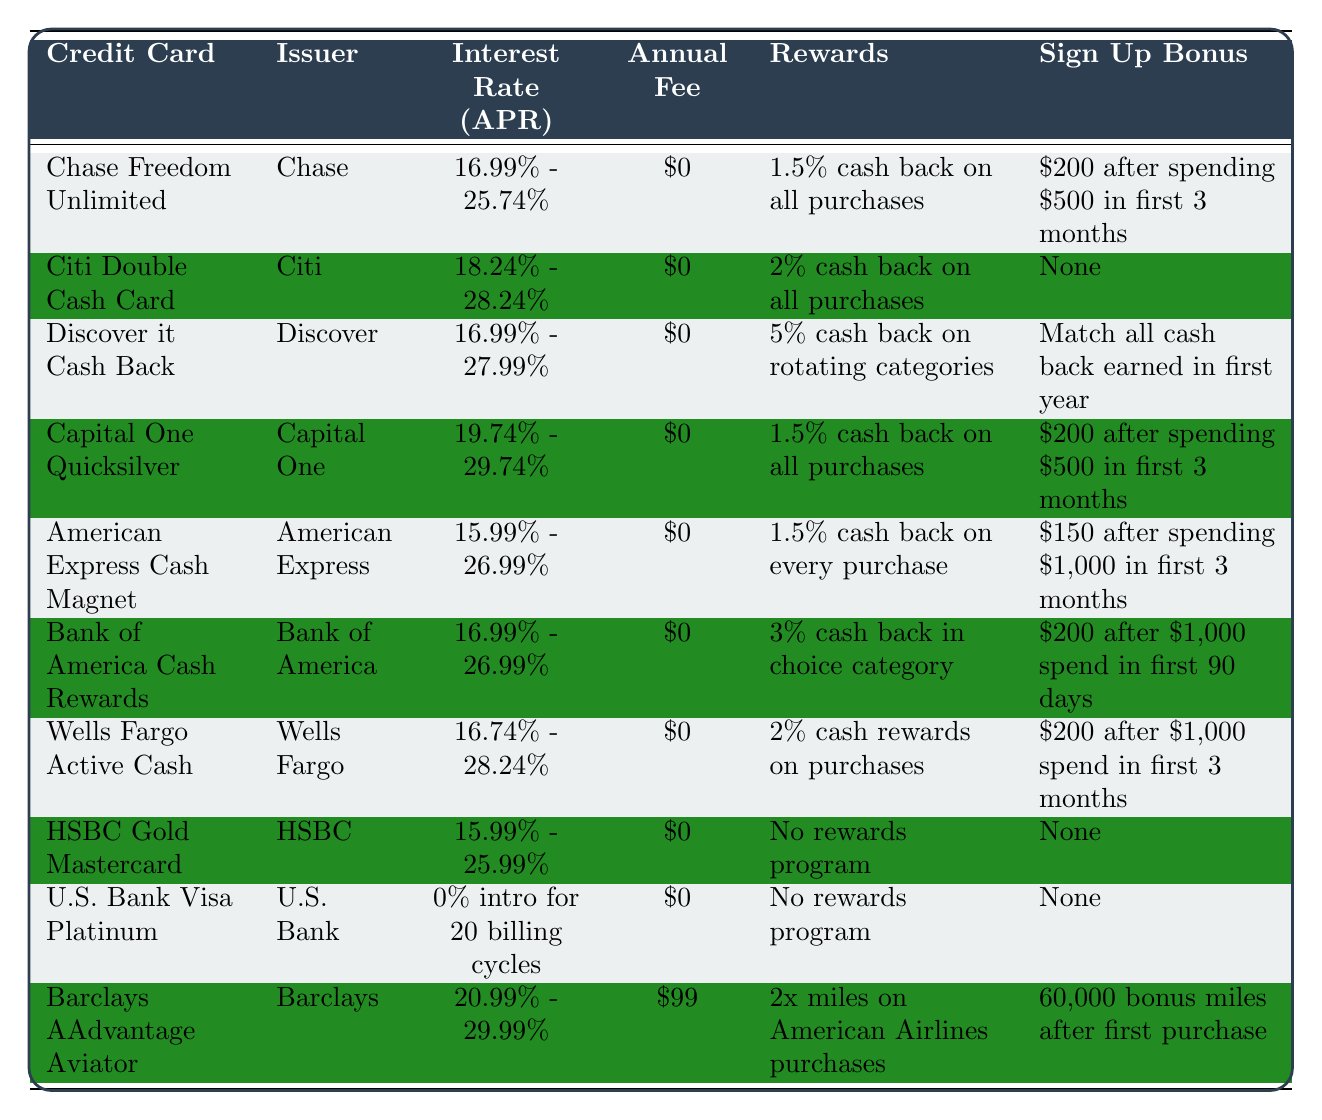What is the lowest interest rate offered among the credit cards in the table? The U.S. Bank Visa Platinum Card has a 0% intro interest rate for 20 billing cycles, which is lower than any other card listed in the table.
Answer: 0% Which credit card offers the highest potential interest rate? The Barclays AAdvantage Aviator has the highest interest rate ranging from 20.99% to 29.99%.
Answer: Barclays AAdvantage Aviator How many credit cards have no annual fee? All credit cards listed in the table have an annual fee of $0. Therefore, the count of cards with no annual fee is 10.
Answer: 10 What is the average interest rate range of the credit cards listed in the table? The interest rate ranges are: 16.99% - 25.74%, 18.24% - 28.24%, 16.99% - 27.99%, 19.74% - 29.74%, 15.99% - 26.99%, 16.99% - 26.99%, 16.74% - 28.24%, 15.99% - 25.99%, 0% intro for 20 billing cycles, and 20.99% - 29.99%. To find the average, calculate the midpoints of each range, ignoring the U.S. Bank Visa Platinum as it has a unique condition. The sum of midpoints (21.37, 23.24, 22.49, 24.74, 21.99, 21.99, 22.49, 20.99, N/A) divided by the 9 others gives the average. So, the average is around 21.69%.
Answer: 21.69% Is there a credit card that offers a sign-up bonus and also has an annual fee? The Barclays AAdvantage Aviator does offer a sign-up bonus ($60,000 bonus miles) but also charges an annual fee of $99, making it the only card that satisfies both conditions.
Answer: Yes Which card provides the best cash back rewards option? The Discover it Cash Back offers 5% cash back on rotating categories each quarter, which is higher than the standard rates of other cards that offer 1.5% or 2%.
Answer: Discover it Cash Back Among the cards with a cash back reward of 2% or more, which one has the lowest interest rate? The Wells Fargo Active Cash Card offers 2% cash rewards and has an interest rate range of 16.74% - 28.24%, which is lower than the Citi Double Cash Card (18.24% - 28.24%) that also offers 2%.
Answer: Wells Fargo Active Cash Card What is the sign-up bonus for the Chase Freedom Unlimited? The Chase Freedom Unlimited provides a sign-up bonus of $200 after spending $500 in the first 3 months.
Answer: $200 Which credit card has the highest sign-up bonus and what is it? The Barclays AAdvantage Aviator offers the highest sign-up bonus of 60,000 bonus miles after the first purchase.
Answer: 60,000 bonus miles Do any credit cards have both a cash back rewards program and no annual fee? Yes, all listed credit cards have an annual fee of $0 and most offer cash back rewards programs.
Answer: Yes 